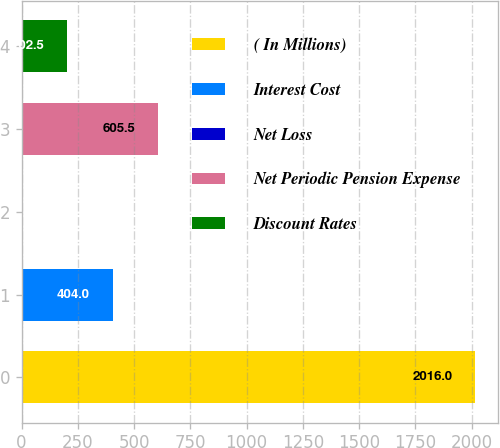<chart> <loc_0><loc_0><loc_500><loc_500><bar_chart><fcel>( In Millions)<fcel>Interest Cost<fcel>Net Loss<fcel>Net Periodic Pension Expense<fcel>Discount Rates<nl><fcel>2016<fcel>404<fcel>1<fcel>605.5<fcel>202.5<nl></chart> 